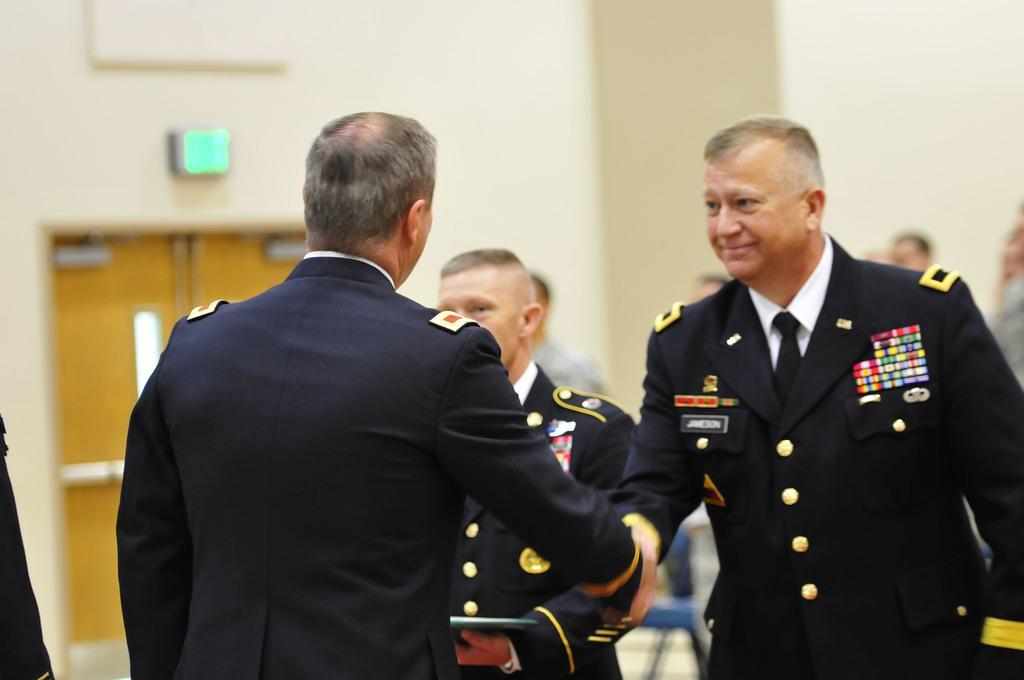Please provide a concise description of this image. This image consists of some persons. All are wearing same dresses. They are in black color. In the middle there are two persons, who are shaking hands. 